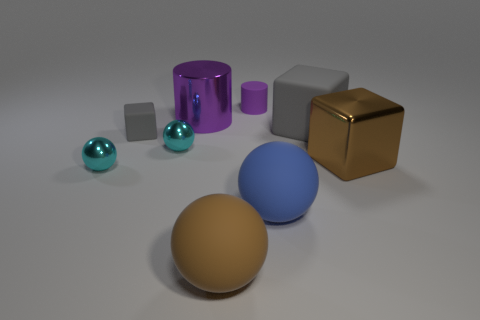Is the material of the large brown object that is on the right side of the blue rubber sphere the same as the big object that is behind the large gray matte cube?
Offer a terse response. Yes. What color is the cylinder that is made of the same material as the big gray thing?
Give a very brief answer. Purple. How many brown matte balls are the same size as the brown metallic object?
Your answer should be very brief. 1. How many other objects are the same color as the big matte block?
Offer a terse response. 1. There is a large brown object right of the blue object; is its shape the same as the gray object right of the tiny gray rubber block?
Your answer should be compact. Yes. There is a purple object that is the same size as the brown sphere; what shape is it?
Ensure brevity in your answer.  Cylinder. Are there an equal number of blocks on the right side of the tiny purple matte object and big spheres that are in front of the blue rubber sphere?
Keep it short and to the point. No. Is there anything else that has the same shape as the brown shiny object?
Your answer should be compact. Yes. Does the cyan sphere that is in front of the large brown metallic thing have the same material as the large purple object?
Provide a succinct answer. Yes. What is the material of the brown ball that is the same size as the blue thing?
Provide a succinct answer. Rubber. 